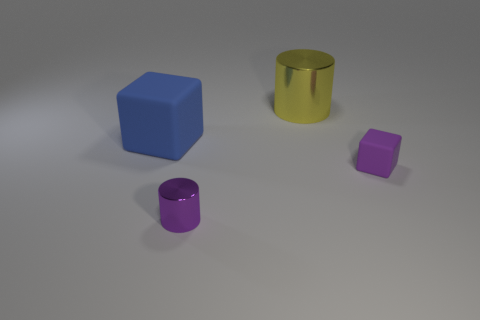How many other things are the same size as the purple shiny object?
Give a very brief answer. 1. What material is the tiny thing in front of the purple object behind the cylinder in front of the tiny purple matte block?
Your answer should be compact. Metal. Is the material of the large blue cube the same as the cube to the right of the big blue rubber object?
Make the answer very short. Yes. Are there fewer big yellow cylinders to the right of the yellow cylinder than rubber things that are in front of the purple metallic object?
Your answer should be very brief. No. How many large brown cylinders are the same material as the big blue block?
Keep it short and to the point. 0. Is there a tiny purple rubber cube behind the matte block on the left side of the metal object behind the small metallic thing?
Keep it short and to the point. No. What number of cylinders are either big yellow things or metal things?
Your answer should be compact. 2. There is a tiny purple matte thing; is it the same shape as the metal thing behind the big rubber block?
Offer a terse response. No. Are there fewer small metal cylinders on the right side of the large yellow metal cylinder than purple shiny cylinders?
Offer a very short reply. Yes. Are there any blue rubber blocks behind the big yellow thing?
Your response must be concise. No. 